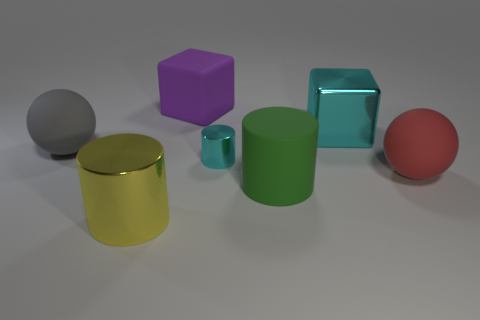Subtract all matte cylinders. How many cylinders are left? 2 Add 2 small blue objects. How many objects exist? 9 Subtract 3 cylinders. How many cylinders are left? 0 Subtract all gray balls. How many balls are left? 1 Subtract all cylinders. How many objects are left? 4 Subtract all red matte balls. Subtract all small cyan cylinders. How many objects are left? 5 Add 2 yellow objects. How many yellow objects are left? 3 Add 7 purple rubber cylinders. How many purple rubber cylinders exist? 7 Subtract 0 blue cubes. How many objects are left? 7 Subtract all blue cylinders. Subtract all blue balls. How many cylinders are left? 3 